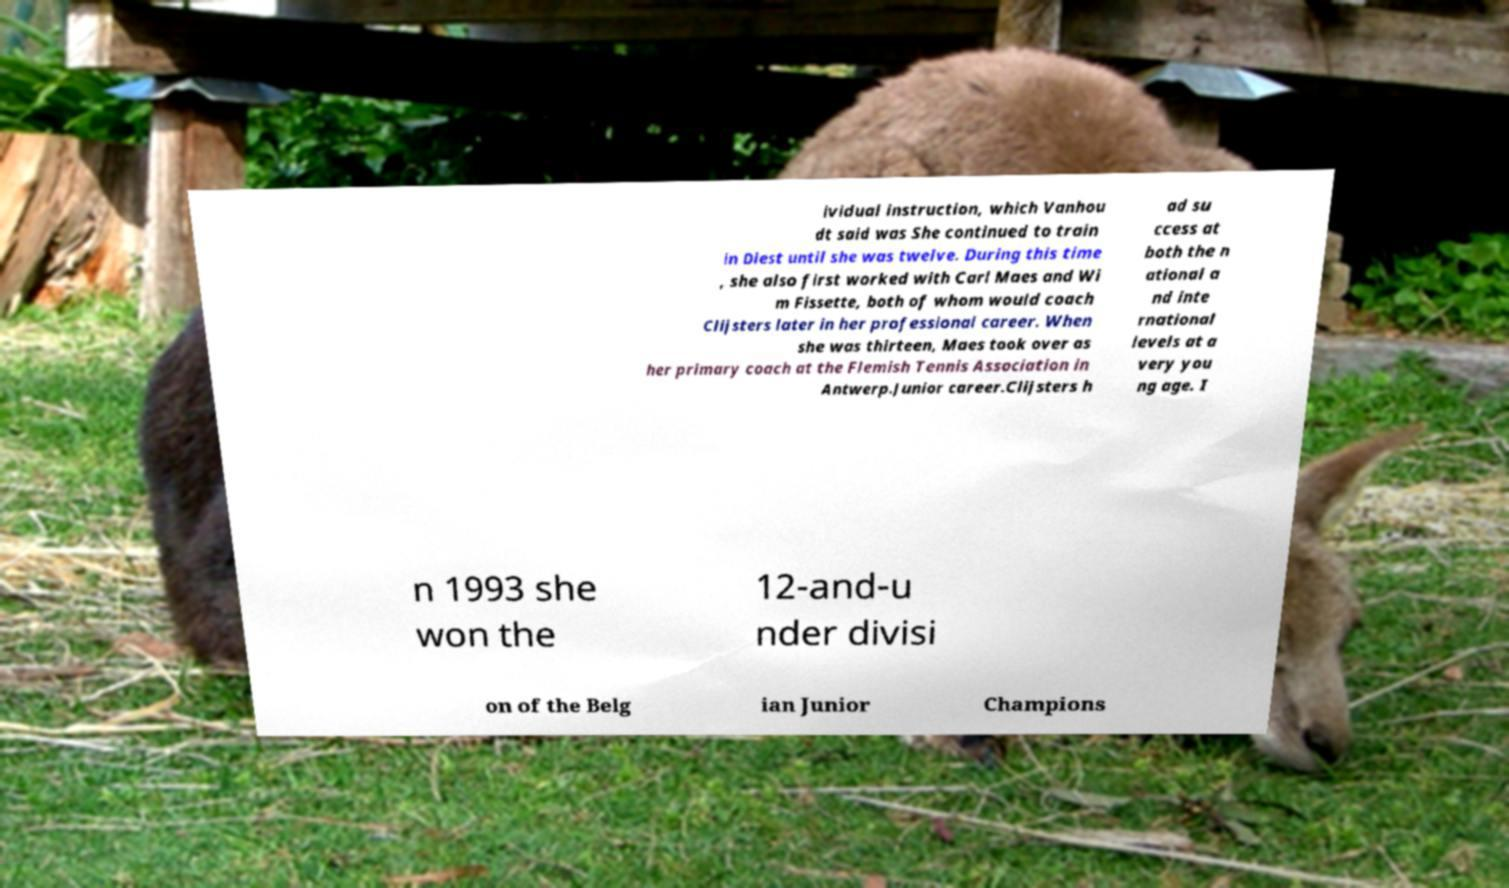Can you accurately transcribe the text from the provided image for me? ividual instruction, which Vanhou dt said was She continued to train in Diest until she was twelve. During this time , she also first worked with Carl Maes and Wi m Fissette, both of whom would coach Clijsters later in her professional career. When she was thirteen, Maes took over as her primary coach at the Flemish Tennis Association in Antwerp.Junior career.Clijsters h ad su ccess at both the n ational a nd inte rnational levels at a very you ng age. I n 1993 she won the 12-and-u nder divisi on of the Belg ian Junior Champions 